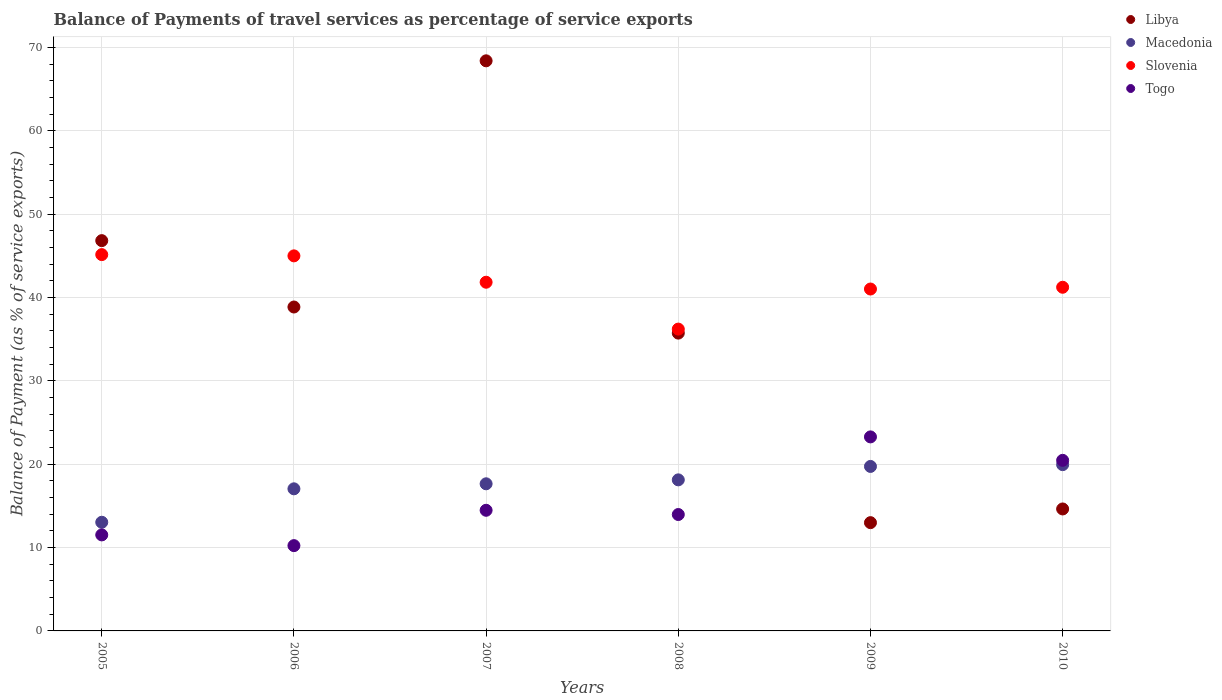How many different coloured dotlines are there?
Give a very brief answer. 4. Is the number of dotlines equal to the number of legend labels?
Offer a terse response. Yes. What is the balance of payments of travel services in Togo in 2008?
Ensure brevity in your answer.  13.96. Across all years, what is the maximum balance of payments of travel services in Macedonia?
Your response must be concise. 19.94. Across all years, what is the minimum balance of payments of travel services in Slovenia?
Your answer should be compact. 36.2. In which year was the balance of payments of travel services in Slovenia maximum?
Offer a very short reply. 2005. What is the total balance of payments of travel services in Slovenia in the graph?
Offer a terse response. 250.4. What is the difference between the balance of payments of travel services in Libya in 2006 and that in 2007?
Offer a terse response. -29.53. What is the difference between the balance of payments of travel services in Slovenia in 2006 and the balance of payments of travel services in Macedonia in 2009?
Give a very brief answer. 25.26. What is the average balance of payments of travel services in Libya per year?
Make the answer very short. 36.23. In the year 2008, what is the difference between the balance of payments of travel services in Macedonia and balance of payments of travel services in Togo?
Your response must be concise. 4.16. What is the ratio of the balance of payments of travel services in Slovenia in 2006 to that in 2010?
Give a very brief answer. 1.09. Is the difference between the balance of payments of travel services in Macedonia in 2006 and 2010 greater than the difference between the balance of payments of travel services in Togo in 2006 and 2010?
Ensure brevity in your answer.  Yes. What is the difference between the highest and the second highest balance of payments of travel services in Macedonia?
Make the answer very short. 0.21. What is the difference between the highest and the lowest balance of payments of travel services in Macedonia?
Keep it short and to the point. 6.91. In how many years, is the balance of payments of travel services in Libya greater than the average balance of payments of travel services in Libya taken over all years?
Keep it short and to the point. 3. Is the sum of the balance of payments of travel services in Slovenia in 2006 and 2007 greater than the maximum balance of payments of travel services in Libya across all years?
Provide a succinct answer. Yes. Is the balance of payments of travel services in Macedonia strictly greater than the balance of payments of travel services in Slovenia over the years?
Provide a succinct answer. No. Is the balance of payments of travel services in Libya strictly less than the balance of payments of travel services in Togo over the years?
Offer a very short reply. No. Does the graph contain any zero values?
Your answer should be compact. No. How many legend labels are there?
Your response must be concise. 4. How are the legend labels stacked?
Offer a terse response. Vertical. What is the title of the graph?
Provide a succinct answer. Balance of Payments of travel services as percentage of service exports. Does "Bahamas" appear as one of the legend labels in the graph?
Provide a succinct answer. No. What is the label or title of the X-axis?
Ensure brevity in your answer.  Years. What is the label or title of the Y-axis?
Your response must be concise. Balance of Payment (as % of service exports). What is the Balance of Payment (as % of service exports) in Libya in 2005?
Ensure brevity in your answer.  46.82. What is the Balance of Payment (as % of service exports) of Macedonia in 2005?
Your answer should be compact. 13.03. What is the Balance of Payment (as % of service exports) of Slovenia in 2005?
Offer a very short reply. 45.14. What is the Balance of Payment (as % of service exports) of Togo in 2005?
Offer a terse response. 11.52. What is the Balance of Payment (as % of service exports) in Libya in 2006?
Your response must be concise. 38.85. What is the Balance of Payment (as % of service exports) in Macedonia in 2006?
Your answer should be very brief. 17.05. What is the Balance of Payment (as % of service exports) in Slovenia in 2006?
Your response must be concise. 44.99. What is the Balance of Payment (as % of service exports) in Togo in 2006?
Keep it short and to the point. 10.23. What is the Balance of Payment (as % of service exports) of Libya in 2007?
Give a very brief answer. 68.39. What is the Balance of Payment (as % of service exports) in Macedonia in 2007?
Offer a terse response. 17.65. What is the Balance of Payment (as % of service exports) in Slovenia in 2007?
Your response must be concise. 41.83. What is the Balance of Payment (as % of service exports) of Togo in 2007?
Ensure brevity in your answer.  14.47. What is the Balance of Payment (as % of service exports) in Libya in 2008?
Keep it short and to the point. 35.72. What is the Balance of Payment (as % of service exports) of Macedonia in 2008?
Make the answer very short. 18.12. What is the Balance of Payment (as % of service exports) of Slovenia in 2008?
Make the answer very short. 36.2. What is the Balance of Payment (as % of service exports) of Togo in 2008?
Your answer should be compact. 13.96. What is the Balance of Payment (as % of service exports) of Libya in 2009?
Keep it short and to the point. 12.99. What is the Balance of Payment (as % of service exports) in Macedonia in 2009?
Your answer should be very brief. 19.73. What is the Balance of Payment (as % of service exports) in Slovenia in 2009?
Make the answer very short. 41.01. What is the Balance of Payment (as % of service exports) of Togo in 2009?
Make the answer very short. 23.27. What is the Balance of Payment (as % of service exports) in Libya in 2010?
Make the answer very short. 14.63. What is the Balance of Payment (as % of service exports) of Macedonia in 2010?
Keep it short and to the point. 19.94. What is the Balance of Payment (as % of service exports) in Slovenia in 2010?
Your answer should be compact. 41.22. What is the Balance of Payment (as % of service exports) of Togo in 2010?
Provide a short and direct response. 20.46. Across all years, what is the maximum Balance of Payment (as % of service exports) in Libya?
Offer a terse response. 68.39. Across all years, what is the maximum Balance of Payment (as % of service exports) in Macedonia?
Provide a succinct answer. 19.94. Across all years, what is the maximum Balance of Payment (as % of service exports) of Slovenia?
Your response must be concise. 45.14. Across all years, what is the maximum Balance of Payment (as % of service exports) of Togo?
Your answer should be compact. 23.27. Across all years, what is the minimum Balance of Payment (as % of service exports) in Libya?
Ensure brevity in your answer.  12.99. Across all years, what is the minimum Balance of Payment (as % of service exports) of Macedonia?
Offer a terse response. 13.03. Across all years, what is the minimum Balance of Payment (as % of service exports) of Slovenia?
Provide a short and direct response. 36.2. Across all years, what is the minimum Balance of Payment (as % of service exports) of Togo?
Provide a succinct answer. 10.23. What is the total Balance of Payment (as % of service exports) in Libya in the graph?
Provide a short and direct response. 217.4. What is the total Balance of Payment (as % of service exports) in Macedonia in the graph?
Your response must be concise. 105.52. What is the total Balance of Payment (as % of service exports) in Slovenia in the graph?
Provide a succinct answer. 250.4. What is the total Balance of Payment (as % of service exports) of Togo in the graph?
Offer a very short reply. 93.92. What is the difference between the Balance of Payment (as % of service exports) of Libya in 2005 and that in 2006?
Provide a succinct answer. 7.96. What is the difference between the Balance of Payment (as % of service exports) in Macedonia in 2005 and that in 2006?
Offer a very short reply. -4.01. What is the difference between the Balance of Payment (as % of service exports) in Slovenia in 2005 and that in 2006?
Give a very brief answer. 0.15. What is the difference between the Balance of Payment (as % of service exports) in Togo in 2005 and that in 2006?
Make the answer very short. 1.29. What is the difference between the Balance of Payment (as % of service exports) in Libya in 2005 and that in 2007?
Provide a short and direct response. -21.57. What is the difference between the Balance of Payment (as % of service exports) in Macedonia in 2005 and that in 2007?
Keep it short and to the point. -4.61. What is the difference between the Balance of Payment (as % of service exports) of Slovenia in 2005 and that in 2007?
Give a very brief answer. 3.31. What is the difference between the Balance of Payment (as % of service exports) of Togo in 2005 and that in 2007?
Give a very brief answer. -2.95. What is the difference between the Balance of Payment (as % of service exports) of Libya in 2005 and that in 2008?
Provide a short and direct response. 11.09. What is the difference between the Balance of Payment (as % of service exports) of Macedonia in 2005 and that in 2008?
Your answer should be compact. -5.09. What is the difference between the Balance of Payment (as % of service exports) of Slovenia in 2005 and that in 2008?
Give a very brief answer. 8.94. What is the difference between the Balance of Payment (as % of service exports) in Togo in 2005 and that in 2008?
Give a very brief answer. -2.44. What is the difference between the Balance of Payment (as % of service exports) of Libya in 2005 and that in 2009?
Give a very brief answer. 33.83. What is the difference between the Balance of Payment (as % of service exports) of Macedonia in 2005 and that in 2009?
Ensure brevity in your answer.  -6.7. What is the difference between the Balance of Payment (as % of service exports) of Slovenia in 2005 and that in 2009?
Give a very brief answer. 4.13. What is the difference between the Balance of Payment (as % of service exports) of Togo in 2005 and that in 2009?
Provide a succinct answer. -11.76. What is the difference between the Balance of Payment (as % of service exports) in Libya in 2005 and that in 2010?
Give a very brief answer. 32.19. What is the difference between the Balance of Payment (as % of service exports) in Macedonia in 2005 and that in 2010?
Provide a short and direct response. -6.91. What is the difference between the Balance of Payment (as % of service exports) of Slovenia in 2005 and that in 2010?
Your answer should be very brief. 3.92. What is the difference between the Balance of Payment (as % of service exports) in Togo in 2005 and that in 2010?
Ensure brevity in your answer.  -8.94. What is the difference between the Balance of Payment (as % of service exports) in Libya in 2006 and that in 2007?
Your answer should be very brief. -29.53. What is the difference between the Balance of Payment (as % of service exports) in Macedonia in 2006 and that in 2007?
Your answer should be compact. -0.6. What is the difference between the Balance of Payment (as % of service exports) in Slovenia in 2006 and that in 2007?
Provide a short and direct response. 3.16. What is the difference between the Balance of Payment (as % of service exports) in Togo in 2006 and that in 2007?
Give a very brief answer. -4.24. What is the difference between the Balance of Payment (as % of service exports) in Libya in 2006 and that in 2008?
Offer a very short reply. 3.13. What is the difference between the Balance of Payment (as % of service exports) of Macedonia in 2006 and that in 2008?
Your answer should be very brief. -1.08. What is the difference between the Balance of Payment (as % of service exports) in Slovenia in 2006 and that in 2008?
Ensure brevity in your answer.  8.79. What is the difference between the Balance of Payment (as % of service exports) of Togo in 2006 and that in 2008?
Your response must be concise. -3.73. What is the difference between the Balance of Payment (as % of service exports) in Libya in 2006 and that in 2009?
Provide a short and direct response. 25.87. What is the difference between the Balance of Payment (as % of service exports) in Macedonia in 2006 and that in 2009?
Your answer should be very brief. -2.69. What is the difference between the Balance of Payment (as % of service exports) of Slovenia in 2006 and that in 2009?
Your response must be concise. 3.98. What is the difference between the Balance of Payment (as % of service exports) of Togo in 2006 and that in 2009?
Offer a very short reply. -13.04. What is the difference between the Balance of Payment (as % of service exports) of Libya in 2006 and that in 2010?
Your response must be concise. 24.22. What is the difference between the Balance of Payment (as % of service exports) in Macedonia in 2006 and that in 2010?
Keep it short and to the point. -2.9. What is the difference between the Balance of Payment (as % of service exports) in Slovenia in 2006 and that in 2010?
Give a very brief answer. 3.77. What is the difference between the Balance of Payment (as % of service exports) in Togo in 2006 and that in 2010?
Ensure brevity in your answer.  -10.23. What is the difference between the Balance of Payment (as % of service exports) in Libya in 2007 and that in 2008?
Give a very brief answer. 32.66. What is the difference between the Balance of Payment (as % of service exports) of Macedonia in 2007 and that in 2008?
Your answer should be compact. -0.47. What is the difference between the Balance of Payment (as % of service exports) in Slovenia in 2007 and that in 2008?
Your response must be concise. 5.62. What is the difference between the Balance of Payment (as % of service exports) of Togo in 2007 and that in 2008?
Make the answer very short. 0.51. What is the difference between the Balance of Payment (as % of service exports) of Libya in 2007 and that in 2009?
Ensure brevity in your answer.  55.4. What is the difference between the Balance of Payment (as % of service exports) of Macedonia in 2007 and that in 2009?
Give a very brief answer. -2.08. What is the difference between the Balance of Payment (as % of service exports) of Slovenia in 2007 and that in 2009?
Give a very brief answer. 0.81. What is the difference between the Balance of Payment (as % of service exports) of Togo in 2007 and that in 2009?
Ensure brevity in your answer.  -8.8. What is the difference between the Balance of Payment (as % of service exports) in Libya in 2007 and that in 2010?
Provide a short and direct response. 53.76. What is the difference between the Balance of Payment (as % of service exports) in Macedonia in 2007 and that in 2010?
Your answer should be compact. -2.3. What is the difference between the Balance of Payment (as % of service exports) of Slovenia in 2007 and that in 2010?
Your answer should be compact. 0.6. What is the difference between the Balance of Payment (as % of service exports) of Togo in 2007 and that in 2010?
Provide a succinct answer. -5.99. What is the difference between the Balance of Payment (as % of service exports) of Libya in 2008 and that in 2009?
Ensure brevity in your answer.  22.74. What is the difference between the Balance of Payment (as % of service exports) of Macedonia in 2008 and that in 2009?
Ensure brevity in your answer.  -1.61. What is the difference between the Balance of Payment (as % of service exports) in Slovenia in 2008 and that in 2009?
Your response must be concise. -4.81. What is the difference between the Balance of Payment (as % of service exports) of Togo in 2008 and that in 2009?
Keep it short and to the point. -9.31. What is the difference between the Balance of Payment (as % of service exports) in Libya in 2008 and that in 2010?
Make the answer very short. 21.09. What is the difference between the Balance of Payment (as % of service exports) of Macedonia in 2008 and that in 2010?
Offer a very short reply. -1.82. What is the difference between the Balance of Payment (as % of service exports) in Slovenia in 2008 and that in 2010?
Your answer should be very brief. -5.02. What is the difference between the Balance of Payment (as % of service exports) in Togo in 2008 and that in 2010?
Your answer should be very brief. -6.5. What is the difference between the Balance of Payment (as % of service exports) of Libya in 2009 and that in 2010?
Ensure brevity in your answer.  -1.64. What is the difference between the Balance of Payment (as % of service exports) in Macedonia in 2009 and that in 2010?
Your response must be concise. -0.21. What is the difference between the Balance of Payment (as % of service exports) in Slovenia in 2009 and that in 2010?
Make the answer very short. -0.21. What is the difference between the Balance of Payment (as % of service exports) of Togo in 2009 and that in 2010?
Give a very brief answer. 2.81. What is the difference between the Balance of Payment (as % of service exports) in Libya in 2005 and the Balance of Payment (as % of service exports) in Macedonia in 2006?
Give a very brief answer. 29.77. What is the difference between the Balance of Payment (as % of service exports) in Libya in 2005 and the Balance of Payment (as % of service exports) in Slovenia in 2006?
Provide a succinct answer. 1.83. What is the difference between the Balance of Payment (as % of service exports) of Libya in 2005 and the Balance of Payment (as % of service exports) of Togo in 2006?
Offer a very short reply. 36.59. What is the difference between the Balance of Payment (as % of service exports) in Macedonia in 2005 and the Balance of Payment (as % of service exports) in Slovenia in 2006?
Keep it short and to the point. -31.96. What is the difference between the Balance of Payment (as % of service exports) in Macedonia in 2005 and the Balance of Payment (as % of service exports) in Togo in 2006?
Ensure brevity in your answer.  2.8. What is the difference between the Balance of Payment (as % of service exports) of Slovenia in 2005 and the Balance of Payment (as % of service exports) of Togo in 2006?
Provide a short and direct response. 34.91. What is the difference between the Balance of Payment (as % of service exports) in Libya in 2005 and the Balance of Payment (as % of service exports) in Macedonia in 2007?
Your answer should be very brief. 29.17. What is the difference between the Balance of Payment (as % of service exports) in Libya in 2005 and the Balance of Payment (as % of service exports) in Slovenia in 2007?
Offer a very short reply. 4.99. What is the difference between the Balance of Payment (as % of service exports) in Libya in 2005 and the Balance of Payment (as % of service exports) in Togo in 2007?
Ensure brevity in your answer.  32.35. What is the difference between the Balance of Payment (as % of service exports) of Macedonia in 2005 and the Balance of Payment (as % of service exports) of Slovenia in 2007?
Your answer should be very brief. -28.79. What is the difference between the Balance of Payment (as % of service exports) of Macedonia in 2005 and the Balance of Payment (as % of service exports) of Togo in 2007?
Your response must be concise. -1.44. What is the difference between the Balance of Payment (as % of service exports) of Slovenia in 2005 and the Balance of Payment (as % of service exports) of Togo in 2007?
Your answer should be very brief. 30.67. What is the difference between the Balance of Payment (as % of service exports) in Libya in 2005 and the Balance of Payment (as % of service exports) in Macedonia in 2008?
Offer a very short reply. 28.7. What is the difference between the Balance of Payment (as % of service exports) in Libya in 2005 and the Balance of Payment (as % of service exports) in Slovenia in 2008?
Make the answer very short. 10.61. What is the difference between the Balance of Payment (as % of service exports) of Libya in 2005 and the Balance of Payment (as % of service exports) of Togo in 2008?
Offer a terse response. 32.85. What is the difference between the Balance of Payment (as % of service exports) in Macedonia in 2005 and the Balance of Payment (as % of service exports) in Slovenia in 2008?
Your answer should be very brief. -23.17. What is the difference between the Balance of Payment (as % of service exports) in Macedonia in 2005 and the Balance of Payment (as % of service exports) in Togo in 2008?
Offer a very short reply. -0.93. What is the difference between the Balance of Payment (as % of service exports) of Slovenia in 2005 and the Balance of Payment (as % of service exports) of Togo in 2008?
Give a very brief answer. 31.18. What is the difference between the Balance of Payment (as % of service exports) in Libya in 2005 and the Balance of Payment (as % of service exports) in Macedonia in 2009?
Your answer should be compact. 27.09. What is the difference between the Balance of Payment (as % of service exports) in Libya in 2005 and the Balance of Payment (as % of service exports) in Slovenia in 2009?
Your answer should be very brief. 5.8. What is the difference between the Balance of Payment (as % of service exports) of Libya in 2005 and the Balance of Payment (as % of service exports) of Togo in 2009?
Provide a short and direct response. 23.54. What is the difference between the Balance of Payment (as % of service exports) in Macedonia in 2005 and the Balance of Payment (as % of service exports) in Slovenia in 2009?
Keep it short and to the point. -27.98. What is the difference between the Balance of Payment (as % of service exports) of Macedonia in 2005 and the Balance of Payment (as % of service exports) of Togo in 2009?
Provide a short and direct response. -10.24. What is the difference between the Balance of Payment (as % of service exports) of Slovenia in 2005 and the Balance of Payment (as % of service exports) of Togo in 2009?
Your answer should be compact. 21.87. What is the difference between the Balance of Payment (as % of service exports) of Libya in 2005 and the Balance of Payment (as % of service exports) of Macedonia in 2010?
Provide a succinct answer. 26.87. What is the difference between the Balance of Payment (as % of service exports) of Libya in 2005 and the Balance of Payment (as % of service exports) of Slovenia in 2010?
Provide a succinct answer. 5.59. What is the difference between the Balance of Payment (as % of service exports) in Libya in 2005 and the Balance of Payment (as % of service exports) in Togo in 2010?
Give a very brief answer. 26.35. What is the difference between the Balance of Payment (as % of service exports) of Macedonia in 2005 and the Balance of Payment (as % of service exports) of Slovenia in 2010?
Ensure brevity in your answer.  -28.19. What is the difference between the Balance of Payment (as % of service exports) in Macedonia in 2005 and the Balance of Payment (as % of service exports) in Togo in 2010?
Your response must be concise. -7.43. What is the difference between the Balance of Payment (as % of service exports) in Slovenia in 2005 and the Balance of Payment (as % of service exports) in Togo in 2010?
Your answer should be compact. 24.68. What is the difference between the Balance of Payment (as % of service exports) in Libya in 2006 and the Balance of Payment (as % of service exports) in Macedonia in 2007?
Offer a terse response. 21.21. What is the difference between the Balance of Payment (as % of service exports) of Libya in 2006 and the Balance of Payment (as % of service exports) of Slovenia in 2007?
Ensure brevity in your answer.  -2.97. What is the difference between the Balance of Payment (as % of service exports) of Libya in 2006 and the Balance of Payment (as % of service exports) of Togo in 2007?
Offer a terse response. 24.38. What is the difference between the Balance of Payment (as % of service exports) in Macedonia in 2006 and the Balance of Payment (as % of service exports) in Slovenia in 2007?
Give a very brief answer. -24.78. What is the difference between the Balance of Payment (as % of service exports) in Macedonia in 2006 and the Balance of Payment (as % of service exports) in Togo in 2007?
Provide a short and direct response. 2.57. What is the difference between the Balance of Payment (as % of service exports) in Slovenia in 2006 and the Balance of Payment (as % of service exports) in Togo in 2007?
Give a very brief answer. 30.52. What is the difference between the Balance of Payment (as % of service exports) of Libya in 2006 and the Balance of Payment (as % of service exports) of Macedonia in 2008?
Make the answer very short. 20.73. What is the difference between the Balance of Payment (as % of service exports) in Libya in 2006 and the Balance of Payment (as % of service exports) in Slovenia in 2008?
Ensure brevity in your answer.  2.65. What is the difference between the Balance of Payment (as % of service exports) in Libya in 2006 and the Balance of Payment (as % of service exports) in Togo in 2008?
Give a very brief answer. 24.89. What is the difference between the Balance of Payment (as % of service exports) in Macedonia in 2006 and the Balance of Payment (as % of service exports) in Slovenia in 2008?
Your answer should be very brief. -19.16. What is the difference between the Balance of Payment (as % of service exports) of Macedonia in 2006 and the Balance of Payment (as % of service exports) of Togo in 2008?
Make the answer very short. 3.08. What is the difference between the Balance of Payment (as % of service exports) in Slovenia in 2006 and the Balance of Payment (as % of service exports) in Togo in 2008?
Offer a terse response. 31.03. What is the difference between the Balance of Payment (as % of service exports) of Libya in 2006 and the Balance of Payment (as % of service exports) of Macedonia in 2009?
Keep it short and to the point. 19.12. What is the difference between the Balance of Payment (as % of service exports) in Libya in 2006 and the Balance of Payment (as % of service exports) in Slovenia in 2009?
Offer a terse response. -2.16. What is the difference between the Balance of Payment (as % of service exports) of Libya in 2006 and the Balance of Payment (as % of service exports) of Togo in 2009?
Your answer should be compact. 15.58. What is the difference between the Balance of Payment (as % of service exports) in Macedonia in 2006 and the Balance of Payment (as % of service exports) in Slovenia in 2009?
Your response must be concise. -23.97. What is the difference between the Balance of Payment (as % of service exports) of Macedonia in 2006 and the Balance of Payment (as % of service exports) of Togo in 2009?
Ensure brevity in your answer.  -6.23. What is the difference between the Balance of Payment (as % of service exports) of Slovenia in 2006 and the Balance of Payment (as % of service exports) of Togo in 2009?
Provide a short and direct response. 21.72. What is the difference between the Balance of Payment (as % of service exports) of Libya in 2006 and the Balance of Payment (as % of service exports) of Macedonia in 2010?
Provide a succinct answer. 18.91. What is the difference between the Balance of Payment (as % of service exports) of Libya in 2006 and the Balance of Payment (as % of service exports) of Slovenia in 2010?
Give a very brief answer. -2.37. What is the difference between the Balance of Payment (as % of service exports) in Libya in 2006 and the Balance of Payment (as % of service exports) in Togo in 2010?
Provide a short and direct response. 18.39. What is the difference between the Balance of Payment (as % of service exports) of Macedonia in 2006 and the Balance of Payment (as % of service exports) of Slovenia in 2010?
Make the answer very short. -24.18. What is the difference between the Balance of Payment (as % of service exports) of Macedonia in 2006 and the Balance of Payment (as % of service exports) of Togo in 2010?
Offer a very short reply. -3.42. What is the difference between the Balance of Payment (as % of service exports) of Slovenia in 2006 and the Balance of Payment (as % of service exports) of Togo in 2010?
Your response must be concise. 24.53. What is the difference between the Balance of Payment (as % of service exports) in Libya in 2007 and the Balance of Payment (as % of service exports) in Macedonia in 2008?
Offer a terse response. 50.27. What is the difference between the Balance of Payment (as % of service exports) of Libya in 2007 and the Balance of Payment (as % of service exports) of Slovenia in 2008?
Give a very brief answer. 32.18. What is the difference between the Balance of Payment (as % of service exports) in Libya in 2007 and the Balance of Payment (as % of service exports) in Togo in 2008?
Make the answer very short. 54.42. What is the difference between the Balance of Payment (as % of service exports) of Macedonia in 2007 and the Balance of Payment (as % of service exports) of Slovenia in 2008?
Offer a terse response. -18.56. What is the difference between the Balance of Payment (as % of service exports) in Macedonia in 2007 and the Balance of Payment (as % of service exports) in Togo in 2008?
Your response must be concise. 3.68. What is the difference between the Balance of Payment (as % of service exports) in Slovenia in 2007 and the Balance of Payment (as % of service exports) in Togo in 2008?
Provide a short and direct response. 27.86. What is the difference between the Balance of Payment (as % of service exports) in Libya in 2007 and the Balance of Payment (as % of service exports) in Macedonia in 2009?
Keep it short and to the point. 48.66. What is the difference between the Balance of Payment (as % of service exports) of Libya in 2007 and the Balance of Payment (as % of service exports) of Slovenia in 2009?
Offer a terse response. 27.38. What is the difference between the Balance of Payment (as % of service exports) in Libya in 2007 and the Balance of Payment (as % of service exports) in Togo in 2009?
Your answer should be very brief. 45.11. What is the difference between the Balance of Payment (as % of service exports) in Macedonia in 2007 and the Balance of Payment (as % of service exports) in Slovenia in 2009?
Your answer should be compact. -23.36. What is the difference between the Balance of Payment (as % of service exports) of Macedonia in 2007 and the Balance of Payment (as % of service exports) of Togo in 2009?
Your answer should be very brief. -5.63. What is the difference between the Balance of Payment (as % of service exports) in Slovenia in 2007 and the Balance of Payment (as % of service exports) in Togo in 2009?
Offer a terse response. 18.55. What is the difference between the Balance of Payment (as % of service exports) of Libya in 2007 and the Balance of Payment (as % of service exports) of Macedonia in 2010?
Provide a short and direct response. 48.44. What is the difference between the Balance of Payment (as % of service exports) of Libya in 2007 and the Balance of Payment (as % of service exports) of Slovenia in 2010?
Provide a short and direct response. 27.16. What is the difference between the Balance of Payment (as % of service exports) in Libya in 2007 and the Balance of Payment (as % of service exports) in Togo in 2010?
Provide a short and direct response. 47.92. What is the difference between the Balance of Payment (as % of service exports) of Macedonia in 2007 and the Balance of Payment (as % of service exports) of Slovenia in 2010?
Give a very brief answer. -23.58. What is the difference between the Balance of Payment (as % of service exports) of Macedonia in 2007 and the Balance of Payment (as % of service exports) of Togo in 2010?
Make the answer very short. -2.81. What is the difference between the Balance of Payment (as % of service exports) of Slovenia in 2007 and the Balance of Payment (as % of service exports) of Togo in 2010?
Your answer should be very brief. 21.36. What is the difference between the Balance of Payment (as % of service exports) in Libya in 2008 and the Balance of Payment (as % of service exports) in Macedonia in 2009?
Ensure brevity in your answer.  15.99. What is the difference between the Balance of Payment (as % of service exports) of Libya in 2008 and the Balance of Payment (as % of service exports) of Slovenia in 2009?
Provide a short and direct response. -5.29. What is the difference between the Balance of Payment (as % of service exports) of Libya in 2008 and the Balance of Payment (as % of service exports) of Togo in 2009?
Make the answer very short. 12.45. What is the difference between the Balance of Payment (as % of service exports) of Macedonia in 2008 and the Balance of Payment (as % of service exports) of Slovenia in 2009?
Ensure brevity in your answer.  -22.89. What is the difference between the Balance of Payment (as % of service exports) of Macedonia in 2008 and the Balance of Payment (as % of service exports) of Togo in 2009?
Your response must be concise. -5.15. What is the difference between the Balance of Payment (as % of service exports) of Slovenia in 2008 and the Balance of Payment (as % of service exports) of Togo in 2009?
Ensure brevity in your answer.  12.93. What is the difference between the Balance of Payment (as % of service exports) in Libya in 2008 and the Balance of Payment (as % of service exports) in Macedonia in 2010?
Offer a very short reply. 15.78. What is the difference between the Balance of Payment (as % of service exports) of Libya in 2008 and the Balance of Payment (as % of service exports) of Slovenia in 2010?
Provide a succinct answer. -5.5. What is the difference between the Balance of Payment (as % of service exports) of Libya in 2008 and the Balance of Payment (as % of service exports) of Togo in 2010?
Your response must be concise. 15.26. What is the difference between the Balance of Payment (as % of service exports) in Macedonia in 2008 and the Balance of Payment (as % of service exports) in Slovenia in 2010?
Your answer should be very brief. -23.1. What is the difference between the Balance of Payment (as % of service exports) in Macedonia in 2008 and the Balance of Payment (as % of service exports) in Togo in 2010?
Provide a succinct answer. -2.34. What is the difference between the Balance of Payment (as % of service exports) in Slovenia in 2008 and the Balance of Payment (as % of service exports) in Togo in 2010?
Make the answer very short. 15.74. What is the difference between the Balance of Payment (as % of service exports) in Libya in 2009 and the Balance of Payment (as % of service exports) in Macedonia in 2010?
Ensure brevity in your answer.  -6.96. What is the difference between the Balance of Payment (as % of service exports) of Libya in 2009 and the Balance of Payment (as % of service exports) of Slovenia in 2010?
Offer a very short reply. -28.24. What is the difference between the Balance of Payment (as % of service exports) of Libya in 2009 and the Balance of Payment (as % of service exports) of Togo in 2010?
Offer a very short reply. -7.48. What is the difference between the Balance of Payment (as % of service exports) in Macedonia in 2009 and the Balance of Payment (as % of service exports) in Slovenia in 2010?
Ensure brevity in your answer.  -21.49. What is the difference between the Balance of Payment (as % of service exports) in Macedonia in 2009 and the Balance of Payment (as % of service exports) in Togo in 2010?
Keep it short and to the point. -0.73. What is the difference between the Balance of Payment (as % of service exports) in Slovenia in 2009 and the Balance of Payment (as % of service exports) in Togo in 2010?
Your response must be concise. 20.55. What is the average Balance of Payment (as % of service exports) in Libya per year?
Keep it short and to the point. 36.23. What is the average Balance of Payment (as % of service exports) of Macedonia per year?
Your response must be concise. 17.59. What is the average Balance of Payment (as % of service exports) of Slovenia per year?
Your answer should be very brief. 41.73. What is the average Balance of Payment (as % of service exports) of Togo per year?
Ensure brevity in your answer.  15.65. In the year 2005, what is the difference between the Balance of Payment (as % of service exports) of Libya and Balance of Payment (as % of service exports) of Macedonia?
Your answer should be very brief. 33.78. In the year 2005, what is the difference between the Balance of Payment (as % of service exports) of Libya and Balance of Payment (as % of service exports) of Slovenia?
Your response must be concise. 1.68. In the year 2005, what is the difference between the Balance of Payment (as % of service exports) in Libya and Balance of Payment (as % of service exports) in Togo?
Give a very brief answer. 35.3. In the year 2005, what is the difference between the Balance of Payment (as % of service exports) of Macedonia and Balance of Payment (as % of service exports) of Slovenia?
Keep it short and to the point. -32.11. In the year 2005, what is the difference between the Balance of Payment (as % of service exports) of Macedonia and Balance of Payment (as % of service exports) of Togo?
Give a very brief answer. 1.51. In the year 2005, what is the difference between the Balance of Payment (as % of service exports) of Slovenia and Balance of Payment (as % of service exports) of Togo?
Your answer should be very brief. 33.62. In the year 2006, what is the difference between the Balance of Payment (as % of service exports) of Libya and Balance of Payment (as % of service exports) of Macedonia?
Keep it short and to the point. 21.81. In the year 2006, what is the difference between the Balance of Payment (as % of service exports) of Libya and Balance of Payment (as % of service exports) of Slovenia?
Your answer should be compact. -6.14. In the year 2006, what is the difference between the Balance of Payment (as % of service exports) of Libya and Balance of Payment (as % of service exports) of Togo?
Give a very brief answer. 28.62. In the year 2006, what is the difference between the Balance of Payment (as % of service exports) in Macedonia and Balance of Payment (as % of service exports) in Slovenia?
Give a very brief answer. -27.94. In the year 2006, what is the difference between the Balance of Payment (as % of service exports) of Macedonia and Balance of Payment (as % of service exports) of Togo?
Make the answer very short. 6.81. In the year 2006, what is the difference between the Balance of Payment (as % of service exports) of Slovenia and Balance of Payment (as % of service exports) of Togo?
Keep it short and to the point. 34.76. In the year 2007, what is the difference between the Balance of Payment (as % of service exports) in Libya and Balance of Payment (as % of service exports) in Macedonia?
Your response must be concise. 50.74. In the year 2007, what is the difference between the Balance of Payment (as % of service exports) in Libya and Balance of Payment (as % of service exports) in Slovenia?
Your response must be concise. 26.56. In the year 2007, what is the difference between the Balance of Payment (as % of service exports) of Libya and Balance of Payment (as % of service exports) of Togo?
Give a very brief answer. 53.92. In the year 2007, what is the difference between the Balance of Payment (as % of service exports) in Macedonia and Balance of Payment (as % of service exports) in Slovenia?
Ensure brevity in your answer.  -24.18. In the year 2007, what is the difference between the Balance of Payment (as % of service exports) in Macedonia and Balance of Payment (as % of service exports) in Togo?
Make the answer very short. 3.18. In the year 2007, what is the difference between the Balance of Payment (as % of service exports) of Slovenia and Balance of Payment (as % of service exports) of Togo?
Keep it short and to the point. 27.36. In the year 2008, what is the difference between the Balance of Payment (as % of service exports) in Libya and Balance of Payment (as % of service exports) in Macedonia?
Offer a very short reply. 17.6. In the year 2008, what is the difference between the Balance of Payment (as % of service exports) of Libya and Balance of Payment (as % of service exports) of Slovenia?
Your answer should be very brief. -0.48. In the year 2008, what is the difference between the Balance of Payment (as % of service exports) in Libya and Balance of Payment (as % of service exports) in Togo?
Give a very brief answer. 21.76. In the year 2008, what is the difference between the Balance of Payment (as % of service exports) in Macedonia and Balance of Payment (as % of service exports) in Slovenia?
Offer a very short reply. -18.08. In the year 2008, what is the difference between the Balance of Payment (as % of service exports) in Macedonia and Balance of Payment (as % of service exports) in Togo?
Make the answer very short. 4.16. In the year 2008, what is the difference between the Balance of Payment (as % of service exports) in Slovenia and Balance of Payment (as % of service exports) in Togo?
Ensure brevity in your answer.  22.24. In the year 2009, what is the difference between the Balance of Payment (as % of service exports) of Libya and Balance of Payment (as % of service exports) of Macedonia?
Your answer should be very brief. -6.74. In the year 2009, what is the difference between the Balance of Payment (as % of service exports) in Libya and Balance of Payment (as % of service exports) in Slovenia?
Provide a short and direct response. -28.03. In the year 2009, what is the difference between the Balance of Payment (as % of service exports) of Libya and Balance of Payment (as % of service exports) of Togo?
Give a very brief answer. -10.29. In the year 2009, what is the difference between the Balance of Payment (as % of service exports) in Macedonia and Balance of Payment (as % of service exports) in Slovenia?
Offer a very short reply. -21.28. In the year 2009, what is the difference between the Balance of Payment (as % of service exports) of Macedonia and Balance of Payment (as % of service exports) of Togo?
Your response must be concise. -3.54. In the year 2009, what is the difference between the Balance of Payment (as % of service exports) in Slovenia and Balance of Payment (as % of service exports) in Togo?
Your response must be concise. 17.74. In the year 2010, what is the difference between the Balance of Payment (as % of service exports) of Libya and Balance of Payment (as % of service exports) of Macedonia?
Give a very brief answer. -5.31. In the year 2010, what is the difference between the Balance of Payment (as % of service exports) in Libya and Balance of Payment (as % of service exports) in Slovenia?
Ensure brevity in your answer.  -26.59. In the year 2010, what is the difference between the Balance of Payment (as % of service exports) of Libya and Balance of Payment (as % of service exports) of Togo?
Provide a succinct answer. -5.83. In the year 2010, what is the difference between the Balance of Payment (as % of service exports) of Macedonia and Balance of Payment (as % of service exports) of Slovenia?
Make the answer very short. -21.28. In the year 2010, what is the difference between the Balance of Payment (as % of service exports) of Macedonia and Balance of Payment (as % of service exports) of Togo?
Provide a succinct answer. -0.52. In the year 2010, what is the difference between the Balance of Payment (as % of service exports) of Slovenia and Balance of Payment (as % of service exports) of Togo?
Provide a succinct answer. 20.76. What is the ratio of the Balance of Payment (as % of service exports) of Libya in 2005 to that in 2006?
Give a very brief answer. 1.2. What is the ratio of the Balance of Payment (as % of service exports) of Macedonia in 2005 to that in 2006?
Offer a terse response. 0.76. What is the ratio of the Balance of Payment (as % of service exports) in Slovenia in 2005 to that in 2006?
Your answer should be compact. 1. What is the ratio of the Balance of Payment (as % of service exports) of Togo in 2005 to that in 2006?
Your answer should be very brief. 1.13. What is the ratio of the Balance of Payment (as % of service exports) in Libya in 2005 to that in 2007?
Your response must be concise. 0.68. What is the ratio of the Balance of Payment (as % of service exports) in Macedonia in 2005 to that in 2007?
Your answer should be very brief. 0.74. What is the ratio of the Balance of Payment (as % of service exports) in Slovenia in 2005 to that in 2007?
Ensure brevity in your answer.  1.08. What is the ratio of the Balance of Payment (as % of service exports) of Togo in 2005 to that in 2007?
Give a very brief answer. 0.8. What is the ratio of the Balance of Payment (as % of service exports) of Libya in 2005 to that in 2008?
Keep it short and to the point. 1.31. What is the ratio of the Balance of Payment (as % of service exports) in Macedonia in 2005 to that in 2008?
Your response must be concise. 0.72. What is the ratio of the Balance of Payment (as % of service exports) of Slovenia in 2005 to that in 2008?
Your response must be concise. 1.25. What is the ratio of the Balance of Payment (as % of service exports) of Togo in 2005 to that in 2008?
Your answer should be compact. 0.82. What is the ratio of the Balance of Payment (as % of service exports) of Libya in 2005 to that in 2009?
Provide a short and direct response. 3.6. What is the ratio of the Balance of Payment (as % of service exports) of Macedonia in 2005 to that in 2009?
Provide a succinct answer. 0.66. What is the ratio of the Balance of Payment (as % of service exports) in Slovenia in 2005 to that in 2009?
Keep it short and to the point. 1.1. What is the ratio of the Balance of Payment (as % of service exports) of Togo in 2005 to that in 2009?
Provide a succinct answer. 0.49. What is the ratio of the Balance of Payment (as % of service exports) in Libya in 2005 to that in 2010?
Your response must be concise. 3.2. What is the ratio of the Balance of Payment (as % of service exports) in Macedonia in 2005 to that in 2010?
Offer a terse response. 0.65. What is the ratio of the Balance of Payment (as % of service exports) of Slovenia in 2005 to that in 2010?
Give a very brief answer. 1.09. What is the ratio of the Balance of Payment (as % of service exports) in Togo in 2005 to that in 2010?
Offer a very short reply. 0.56. What is the ratio of the Balance of Payment (as % of service exports) in Libya in 2006 to that in 2007?
Your answer should be compact. 0.57. What is the ratio of the Balance of Payment (as % of service exports) in Macedonia in 2006 to that in 2007?
Your response must be concise. 0.97. What is the ratio of the Balance of Payment (as % of service exports) of Slovenia in 2006 to that in 2007?
Your answer should be very brief. 1.08. What is the ratio of the Balance of Payment (as % of service exports) of Togo in 2006 to that in 2007?
Make the answer very short. 0.71. What is the ratio of the Balance of Payment (as % of service exports) of Libya in 2006 to that in 2008?
Your answer should be compact. 1.09. What is the ratio of the Balance of Payment (as % of service exports) of Macedonia in 2006 to that in 2008?
Your answer should be very brief. 0.94. What is the ratio of the Balance of Payment (as % of service exports) of Slovenia in 2006 to that in 2008?
Ensure brevity in your answer.  1.24. What is the ratio of the Balance of Payment (as % of service exports) of Togo in 2006 to that in 2008?
Your answer should be compact. 0.73. What is the ratio of the Balance of Payment (as % of service exports) of Libya in 2006 to that in 2009?
Give a very brief answer. 2.99. What is the ratio of the Balance of Payment (as % of service exports) in Macedonia in 2006 to that in 2009?
Make the answer very short. 0.86. What is the ratio of the Balance of Payment (as % of service exports) of Slovenia in 2006 to that in 2009?
Provide a succinct answer. 1.1. What is the ratio of the Balance of Payment (as % of service exports) in Togo in 2006 to that in 2009?
Keep it short and to the point. 0.44. What is the ratio of the Balance of Payment (as % of service exports) of Libya in 2006 to that in 2010?
Provide a short and direct response. 2.66. What is the ratio of the Balance of Payment (as % of service exports) of Macedonia in 2006 to that in 2010?
Ensure brevity in your answer.  0.85. What is the ratio of the Balance of Payment (as % of service exports) in Slovenia in 2006 to that in 2010?
Provide a short and direct response. 1.09. What is the ratio of the Balance of Payment (as % of service exports) of Togo in 2006 to that in 2010?
Ensure brevity in your answer.  0.5. What is the ratio of the Balance of Payment (as % of service exports) in Libya in 2007 to that in 2008?
Provide a succinct answer. 1.91. What is the ratio of the Balance of Payment (as % of service exports) of Macedonia in 2007 to that in 2008?
Offer a very short reply. 0.97. What is the ratio of the Balance of Payment (as % of service exports) in Slovenia in 2007 to that in 2008?
Provide a short and direct response. 1.16. What is the ratio of the Balance of Payment (as % of service exports) of Togo in 2007 to that in 2008?
Provide a succinct answer. 1.04. What is the ratio of the Balance of Payment (as % of service exports) of Libya in 2007 to that in 2009?
Your answer should be very brief. 5.27. What is the ratio of the Balance of Payment (as % of service exports) in Macedonia in 2007 to that in 2009?
Ensure brevity in your answer.  0.89. What is the ratio of the Balance of Payment (as % of service exports) of Slovenia in 2007 to that in 2009?
Your answer should be very brief. 1.02. What is the ratio of the Balance of Payment (as % of service exports) of Togo in 2007 to that in 2009?
Offer a very short reply. 0.62. What is the ratio of the Balance of Payment (as % of service exports) in Libya in 2007 to that in 2010?
Provide a succinct answer. 4.67. What is the ratio of the Balance of Payment (as % of service exports) of Macedonia in 2007 to that in 2010?
Ensure brevity in your answer.  0.88. What is the ratio of the Balance of Payment (as % of service exports) in Slovenia in 2007 to that in 2010?
Offer a very short reply. 1.01. What is the ratio of the Balance of Payment (as % of service exports) of Togo in 2007 to that in 2010?
Offer a terse response. 0.71. What is the ratio of the Balance of Payment (as % of service exports) in Libya in 2008 to that in 2009?
Keep it short and to the point. 2.75. What is the ratio of the Balance of Payment (as % of service exports) in Macedonia in 2008 to that in 2009?
Provide a short and direct response. 0.92. What is the ratio of the Balance of Payment (as % of service exports) in Slovenia in 2008 to that in 2009?
Offer a very short reply. 0.88. What is the ratio of the Balance of Payment (as % of service exports) of Togo in 2008 to that in 2009?
Give a very brief answer. 0.6. What is the ratio of the Balance of Payment (as % of service exports) of Libya in 2008 to that in 2010?
Keep it short and to the point. 2.44. What is the ratio of the Balance of Payment (as % of service exports) of Macedonia in 2008 to that in 2010?
Keep it short and to the point. 0.91. What is the ratio of the Balance of Payment (as % of service exports) in Slovenia in 2008 to that in 2010?
Provide a succinct answer. 0.88. What is the ratio of the Balance of Payment (as % of service exports) in Togo in 2008 to that in 2010?
Your response must be concise. 0.68. What is the ratio of the Balance of Payment (as % of service exports) in Libya in 2009 to that in 2010?
Make the answer very short. 0.89. What is the ratio of the Balance of Payment (as % of service exports) of Macedonia in 2009 to that in 2010?
Keep it short and to the point. 0.99. What is the ratio of the Balance of Payment (as % of service exports) of Togo in 2009 to that in 2010?
Ensure brevity in your answer.  1.14. What is the difference between the highest and the second highest Balance of Payment (as % of service exports) of Libya?
Keep it short and to the point. 21.57. What is the difference between the highest and the second highest Balance of Payment (as % of service exports) in Macedonia?
Provide a succinct answer. 0.21. What is the difference between the highest and the second highest Balance of Payment (as % of service exports) in Slovenia?
Keep it short and to the point. 0.15. What is the difference between the highest and the second highest Balance of Payment (as % of service exports) in Togo?
Ensure brevity in your answer.  2.81. What is the difference between the highest and the lowest Balance of Payment (as % of service exports) of Libya?
Keep it short and to the point. 55.4. What is the difference between the highest and the lowest Balance of Payment (as % of service exports) of Macedonia?
Provide a succinct answer. 6.91. What is the difference between the highest and the lowest Balance of Payment (as % of service exports) of Slovenia?
Provide a short and direct response. 8.94. What is the difference between the highest and the lowest Balance of Payment (as % of service exports) of Togo?
Your answer should be very brief. 13.04. 